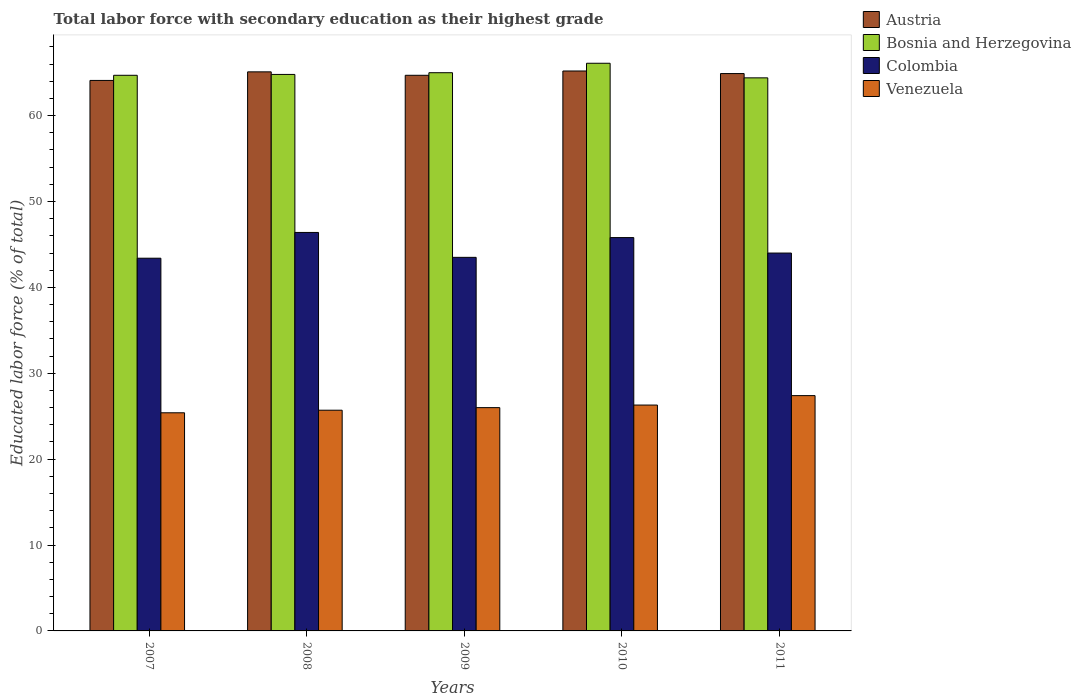How many groups of bars are there?
Your response must be concise. 5. How many bars are there on the 2nd tick from the left?
Offer a very short reply. 4. What is the label of the 1st group of bars from the left?
Offer a very short reply. 2007. In how many cases, is the number of bars for a given year not equal to the number of legend labels?
Your response must be concise. 0. What is the percentage of total labor force with primary education in Austria in 2008?
Ensure brevity in your answer.  65.1. Across all years, what is the maximum percentage of total labor force with primary education in Venezuela?
Your response must be concise. 27.4. Across all years, what is the minimum percentage of total labor force with primary education in Bosnia and Herzegovina?
Your answer should be compact. 64.4. In which year was the percentage of total labor force with primary education in Bosnia and Herzegovina maximum?
Your answer should be compact. 2010. In which year was the percentage of total labor force with primary education in Austria minimum?
Keep it short and to the point. 2007. What is the total percentage of total labor force with primary education in Colombia in the graph?
Make the answer very short. 223.1. What is the difference between the percentage of total labor force with primary education in Colombia in 2007 and that in 2011?
Provide a short and direct response. -0.6. What is the difference between the percentage of total labor force with primary education in Bosnia and Herzegovina in 2007 and the percentage of total labor force with primary education in Austria in 2011?
Provide a succinct answer. -0.2. What is the average percentage of total labor force with primary education in Colombia per year?
Offer a very short reply. 44.62. In the year 2008, what is the difference between the percentage of total labor force with primary education in Venezuela and percentage of total labor force with primary education in Bosnia and Herzegovina?
Give a very brief answer. -39.1. In how many years, is the percentage of total labor force with primary education in Bosnia and Herzegovina greater than 56 %?
Your response must be concise. 5. What is the ratio of the percentage of total labor force with primary education in Venezuela in 2009 to that in 2010?
Give a very brief answer. 0.99. What is the difference between the highest and the second highest percentage of total labor force with primary education in Austria?
Offer a terse response. 0.1. What is the difference between the highest and the lowest percentage of total labor force with primary education in Colombia?
Offer a very short reply. 3. In how many years, is the percentage of total labor force with primary education in Austria greater than the average percentage of total labor force with primary education in Austria taken over all years?
Offer a terse response. 3. Is the sum of the percentage of total labor force with primary education in Venezuela in 2007 and 2009 greater than the maximum percentage of total labor force with primary education in Austria across all years?
Offer a terse response. No. Is it the case that in every year, the sum of the percentage of total labor force with primary education in Bosnia and Herzegovina and percentage of total labor force with primary education in Austria is greater than the sum of percentage of total labor force with primary education in Colombia and percentage of total labor force with primary education in Venezuela?
Give a very brief answer. No. How many bars are there?
Make the answer very short. 20. What is the difference between two consecutive major ticks on the Y-axis?
Your answer should be very brief. 10. Are the values on the major ticks of Y-axis written in scientific E-notation?
Give a very brief answer. No. Does the graph contain any zero values?
Provide a succinct answer. No. Does the graph contain grids?
Give a very brief answer. No. What is the title of the graph?
Your response must be concise. Total labor force with secondary education as their highest grade. What is the label or title of the X-axis?
Your answer should be compact. Years. What is the label or title of the Y-axis?
Offer a very short reply. Educated labor force (% of total). What is the Educated labor force (% of total) of Austria in 2007?
Keep it short and to the point. 64.1. What is the Educated labor force (% of total) of Bosnia and Herzegovina in 2007?
Your response must be concise. 64.7. What is the Educated labor force (% of total) of Colombia in 2007?
Your answer should be compact. 43.4. What is the Educated labor force (% of total) of Venezuela in 2007?
Your answer should be very brief. 25.4. What is the Educated labor force (% of total) of Austria in 2008?
Ensure brevity in your answer.  65.1. What is the Educated labor force (% of total) in Bosnia and Herzegovina in 2008?
Your answer should be compact. 64.8. What is the Educated labor force (% of total) in Colombia in 2008?
Give a very brief answer. 46.4. What is the Educated labor force (% of total) in Venezuela in 2008?
Make the answer very short. 25.7. What is the Educated labor force (% of total) of Austria in 2009?
Give a very brief answer. 64.7. What is the Educated labor force (% of total) in Bosnia and Herzegovina in 2009?
Offer a very short reply. 65. What is the Educated labor force (% of total) in Colombia in 2009?
Your response must be concise. 43.5. What is the Educated labor force (% of total) of Venezuela in 2009?
Keep it short and to the point. 26. What is the Educated labor force (% of total) in Austria in 2010?
Your answer should be very brief. 65.2. What is the Educated labor force (% of total) in Bosnia and Herzegovina in 2010?
Make the answer very short. 66.1. What is the Educated labor force (% of total) in Colombia in 2010?
Keep it short and to the point. 45.8. What is the Educated labor force (% of total) of Venezuela in 2010?
Your answer should be compact. 26.3. What is the Educated labor force (% of total) of Austria in 2011?
Keep it short and to the point. 64.9. What is the Educated labor force (% of total) of Bosnia and Herzegovina in 2011?
Make the answer very short. 64.4. What is the Educated labor force (% of total) in Colombia in 2011?
Your answer should be compact. 44. What is the Educated labor force (% of total) in Venezuela in 2011?
Provide a succinct answer. 27.4. Across all years, what is the maximum Educated labor force (% of total) in Austria?
Make the answer very short. 65.2. Across all years, what is the maximum Educated labor force (% of total) in Bosnia and Herzegovina?
Offer a terse response. 66.1. Across all years, what is the maximum Educated labor force (% of total) of Colombia?
Ensure brevity in your answer.  46.4. Across all years, what is the maximum Educated labor force (% of total) of Venezuela?
Keep it short and to the point. 27.4. Across all years, what is the minimum Educated labor force (% of total) of Austria?
Make the answer very short. 64.1. Across all years, what is the minimum Educated labor force (% of total) of Bosnia and Herzegovina?
Offer a very short reply. 64.4. Across all years, what is the minimum Educated labor force (% of total) in Colombia?
Your answer should be compact. 43.4. Across all years, what is the minimum Educated labor force (% of total) in Venezuela?
Offer a very short reply. 25.4. What is the total Educated labor force (% of total) of Austria in the graph?
Provide a short and direct response. 324. What is the total Educated labor force (% of total) in Bosnia and Herzegovina in the graph?
Offer a very short reply. 325. What is the total Educated labor force (% of total) of Colombia in the graph?
Ensure brevity in your answer.  223.1. What is the total Educated labor force (% of total) in Venezuela in the graph?
Ensure brevity in your answer.  130.8. What is the difference between the Educated labor force (% of total) of Austria in 2007 and that in 2008?
Keep it short and to the point. -1. What is the difference between the Educated labor force (% of total) of Bosnia and Herzegovina in 2007 and that in 2008?
Ensure brevity in your answer.  -0.1. What is the difference between the Educated labor force (% of total) in Venezuela in 2007 and that in 2008?
Offer a very short reply. -0.3. What is the difference between the Educated labor force (% of total) in Austria in 2007 and that in 2009?
Make the answer very short. -0.6. What is the difference between the Educated labor force (% of total) of Bosnia and Herzegovina in 2007 and that in 2009?
Give a very brief answer. -0.3. What is the difference between the Educated labor force (% of total) in Colombia in 2007 and that in 2009?
Provide a short and direct response. -0.1. What is the difference between the Educated labor force (% of total) of Austria in 2007 and that in 2010?
Your response must be concise. -1.1. What is the difference between the Educated labor force (% of total) of Bosnia and Herzegovina in 2007 and that in 2010?
Offer a terse response. -1.4. What is the difference between the Educated labor force (% of total) of Colombia in 2007 and that in 2010?
Ensure brevity in your answer.  -2.4. What is the difference between the Educated labor force (% of total) of Venezuela in 2007 and that in 2010?
Your response must be concise. -0.9. What is the difference between the Educated labor force (% of total) in Austria in 2007 and that in 2011?
Your answer should be compact. -0.8. What is the difference between the Educated labor force (% of total) in Bosnia and Herzegovina in 2007 and that in 2011?
Provide a short and direct response. 0.3. What is the difference between the Educated labor force (% of total) in Colombia in 2007 and that in 2011?
Provide a succinct answer. -0.6. What is the difference between the Educated labor force (% of total) of Bosnia and Herzegovina in 2008 and that in 2009?
Offer a terse response. -0.2. What is the difference between the Educated labor force (% of total) in Colombia in 2008 and that in 2009?
Ensure brevity in your answer.  2.9. What is the difference between the Educated labor force (% of total) in Venezuela in 2008 and that in 2009?
Keep it short and to the point. -0.3. What is the difference between the Educated labor force (% of total) of Austria in 2009 and that in 2010?
Your answer should be compact. -0.5. What is the difference between the Educated labor force (% of total) in Venezuela in 2009 and that in 2010?
Offer a very short reply. -0.3. What is the difference between the Educated labor force (% of total) of Bosnia and Herzegovina in 2009 and that in 2011?
Make the answer very short. 0.6. What is the difference between the Educated labor force (% of total) of Austria in 2010 and that in 2011?
Make the answer very short. 0.3. What is the difference between the Educated labor force (% of total) in Venezuela in 2010 and that in 2011?
Offer a terse response. -1.1. What is the difference between the Educated labor force (% of total) of Austria in 2007 and the Educated labor force (% of total) of Venezuela in 2008?
Keep it short and to the point. 38.4. What is the difference between the Educated labor force (% of total) in Bosnia and Herzegovina in 2007 and the Educated labor force (% of total) in Colombia in 2008?
Offer a very short reply. 18.3. What is the difference between the Educated labor force (% of total) of Bosnia and Herzegovina in 2007 and the Educated labor force (% of total) of Venezuela in 2008?
Ensure brevity in your answer.  39. What is the difference between the Educated labor force (% of total) of Colombia in 2007 and the Educated labor force (% of total) of Venezuela in 2008?
Your response must be concise. 17.7. What is the difference between the Educated labor force (% of total) in Austria in 2007 and the Educated labor force (% of total) in Bosnia and Herzegovina in 2009?
Your answer should be compact. -0.9. What is the difference between the Educated labor force (% of total) of Austria in 2007 and the Educated labor force (% of total) of Colombia in 2009?
Offer a very short reply. 20.6. What is the difference between the Educated labor force (% of total) in Austria in 2007 and the Educated labor force (% of total) in Venezuela in 2009?
Your answer should be compact. 38.1. What is the difference between the Educated labor force (% of total) in Bosnia and Herzegovina in 2007 and the Educated labor force (% of total) in Colombia in 2009?
Your answer should be very brief. 21.2. What is the difference between the Educated labor force (% of total) in Bosnia and Herzegovina in 2007 and the Educated labor force (% of total) in Venezuela in 2009?
Offer a very short reply. 38.7. What is the difference between the Educated labor force (% of total) in Austria in 2007 and the Educated labor force (% of total) in Colombia in 2010?
Your answer should be compact. 18.3. What is the difference between the Educated labor force (% of total) in Austria in 2007 and the Educated labor force (% of total) in Venezuela in 2010?
Provide a short and direct response. 37.8. What is the difference between the Educated labor force (% of total) of Bosnia and Herzegovina in 2007 and the Educated labor force (% of total) of Venezuela in 2010?
Your answer should be very brief. 38.4. What is the difference between the Educated labor force (% of total) of Austria in 2007 and the Educated labor force (% of total) of Bosnia and Herzegovina in 2011?
Offer a very short reply. -0.3. What is the difference between the Educated labor force (% of total) in Austria in 2007 and the Educated labor force (% of total) in Colombia in 2011?
Give a very brief answer. 20.1. What is the difference between the Educated labor force (% of total) in Austria in 2007 and the Educated labor force (% of total) in Venezuela in 2011?
Keep it short and to the point. 36.7. What is the difference between the Educated labor force (% of total) in Bosnia and Herzegovina in 2007 and the Educated labor force (% of total) in Colombia in 2011?
Make the answer very short. 20.7. What is the difference between the Educated labor force (% of total) of Bosnia and Herzegovina in 2007 and the Educated labor force (% of total) of Venezuela in 2011?
Offer a terse response. 37.3. What is the difference between the Educated labor force (% of total) of Colombia in 2007 and the Educated labor force (% of total) of Venezuela in 2011?
Ensure brevity in your answer.  16. What is the difference between the Educated labor force (% of total) in Austria in 2008 and the Educated labor force (% of total) in Colombia in 2009?
Your response must be concise. 21.6. What is the difference between the Educated labor force (% of total) in Austria in 2008 and the Educated labor force (% of total) in Venezuela in 2009?
Your answer should be very brief. 39.1. What is the difference between the Educated labor force (% of total) of Bosnia and Herzegovina in 2008 and the Educated labor force (% of total) of Colombia in 2009?
Give a very brief answer. 21.3. What is the difference between the Educated labor force (% of total) of Bosnia and Herzegovina in 2008 and the Educated labor force (% of total) of Venezuela in 2009?
Keep it short and to the point. 38.8. What is the difference between the Educated labor force (% of total) in Colombia in 2008 and the Educated labor force (% of total) in Venezuela in 2009?
Your answer should be very brief. 20.4. What is the difference between the Educated labor force (% of total) in Austria in 2008 and the Educated labor force (% of total) in Colombia in 2010?
Offer a terse response. 19.3. What is the difference between the Educated labor force (% of total) of Austria in 2008 and the Educated labor force (% of total) of Venezuela in 2010?
Make the answer very short. 38.8. What is the difference between the Educated labor force (% of total) of Bosnia and Herzegovina in 2008 and the Educated labor force (% of total) of Venezuela in 2010?
Ensure brevity in your answer.  38.5. What is the difference between the Educated labor force (% of total) of Colombia in 2008 and the Educated labor force (% of total) of Venezuela in 2010?
Ensure brevity in your answer.  20.1. What is the difference between the Educated labor force (% of total) in Austria in 2008 and the Educated labor force (% of total) in Bosnia and Herzegovina in 2011?
Make the answer very short. 0.7. What is the difference between the Educated labor force (% of total) in Austria in 2008 and the Educated labor force (% of total) in Colombia in 2011?
Provide a short and direct response. 21.1. What is the difference between the Educated labor force (% of total) in Austria in 2008 and the Educated labor force (% of total) in Venezuela in 2011?
Your answer should be very brief. 37.7. What is the difference between the Educated labor force (% of total) in Bosnia and Herzegovina in 2008 and the Educated labor force (% of total) in Colombia in 2011?
Your response must be concise. 20.8. What is the difference between the Educated labor force (% of total) in Bosnia and Herzegovina in 2008 and the Educated labor force (% of total) in Venezuela in 2011?
Offer a terse response. 37.4. What is the difference between the Educated labor force (% of total) in Colombia in 2008 and the Educated labor force (% of total) in Venezuela in 2011?
Make the answer very short. 19. What is the difference between the Educated labor force (% of total) of Austria in 2009 and the Educated labor force (% of total) of Bosnia and Herzegovina in 2010?
Offer a very short reply. -1.4. What is the difference between the Educated labor force (% of total) in Austria in 2009 and the Educated labor force (% of total) in Colombia in 2010?
Ensure brevity in your answer.  18.9. What is the difference between the Educated labor force (% of total) of Austria in 2009 and the Educated labor force (% of total) of Venezuela in 2010?
Offer a terse response. 38.4. What is the difference between the Educated labor force (% of total) of Bosnia and Herzegovina in 2009 and the Educated labor force (% of total) of Venezuela in 2010?
Make the answer very short. 38.7. What is the difference between the Educated labor force (% of total) of Colombia in 2009 and the Educated labor force (% of total) of Venezuela in 2010?
Your answer should be compact. 17.2. What is the difference between the Educated labor force (% of total) of Austria in 2009 and the Educated labor force (% of total) of Colombia in 2011?
Give a very brief answer. 20.7. What is the difference between the Educated labor force (% of total) in Austria in 2009 and the Educated labor force (% of total) in Venezuela in 2011?
Ensure brevity in your answer.  37.3. What is the difference between the Educated labor force (% of total) of Bosnia and Herzegovina in 2009 and the Educated labor force (% of total) of Colombia in 2011?
Offer a terse response. 21. What is the difference between the Educated labor force (% of total) in Bosnia and Herzegovina in 2009 and the Educated labor force (% of total) in Venezuela in 2011?
Offer a terse response. 37.6. What is the difference between the Educated labor force (% of total) in Colombia in 2009 and the Educated labor force (% of total) in Venezuela in 2011?
Provide a succinct answer. 16.1. What is the difference between the Educated labor force (% of total) of Austria in 2010 and the Educated labor force (% of total) of Bosnia and Herzegovina in 2011?
Your answer should be very brief. 0.8. What is the difference between the Educated labor force (% of total) of Austria in 2010 and the Educated labor force (% of total) of Colombia in 2011?
Your answer should be compact. 21.2. What is the difference between the Educated labor force (% of total) in Austria in 2010 and the Educated labor force (% of total) in Venezuela in 2011?
Ensure brevity in your answer.  37.8. What is the difference between the Educated labor force (% of total) of Bosnia and Herzegovina in 2010 and the Educated labor force (% of total) of Colombia in 2011?
Provide a short and direct response. 22.1. What is the difference between the Educated labor force (% of total) of Bosnia and Herzegovina in 2010 and the Educated labor force (% of total) of Venezuela in 2011?
Make the answer very short. 38.7. What is the difference between the Educated labor force (% of total) in Colombia in 2010 and the Educated labor force (% of total) in Venezuela in 2011?
Your answer should be compact. 18.4. What is the average Educated labor force (% of total) in Austria per year?
Your response must be concise. 64.8. What is the average Educated labor force (% of total) of Colombia per year?
Your answer should be very brief. 44.62. What is the average Educated labor force (% of total) in Venezuela per year?
Your answer should be very brief. 26.16. In the year 2007, what is the difference between the Educated labor force (% of total) in Austria and Educated labor force (% of total) in Bosnia and Herzegovina?
Provide a short and direct response. -0.6. In the year 2007, what is the difference between the Educated labor force (% of total) in Austria and Educated labor force (% of total) in Colombia?
Your answer should be compact. 20.7. In the year 2007, what is the difference between the Educated labor force (% of total) of Austria and Educated labor force (% of total) of Venezuela?
Your response must be concise. 38.7. In the year 2007, what is the difference between the Educated labor force (% of total) of Bosnia and Herzegovina and Educated labor force (% of total) of Colombia?
Give a very brief answer. 21.3. In the year 2007, what is the difference between the Educated labor force (% of total) of Bosnia and Herzegovina and Educated labor force (% of total) of Venezuela?
Offer a terse response. 39.3. In the year 2007, what is the difference between the Educated labor force (% of total) of Colombia and Educated labor force (% of total) of Venezuela?
Give a very brief answer. 18. In the year 2008, what is the difference between the Educated labor force (% of total) in Austria and Educated labor force (% of total) in Colombia?
Offer a terse response. 18.7. In the year 2008, what is the difference between the Educated labor force (% of total) in Austria and Educated labor force (% of total) in Venezuela?
Keep it short and to the point. 39.4. In the year 2008, what is the difference between the Educated labor force (% of total) of Bosnia and Herzegovina and Educated labor force (% of total) of Colombia?
Offer a very short reply. 18.4. In the year 2008, what is the difference between the Educated labor force (% of total) of Bosnia and Herzegovina and Educated labor force (% of total) of Venezuela?
Your answer should be compact. 39.1. In the year 2008, what is the difference between the Educated labor force (% of total) in Colombia and Educated labor force (% of total) in Venezuela?
Your answer should be compact. 20.7. In the year 2009, what is the difference between the Educated labor force (% of total) of Austria and Educated labor force (% of total) of Colombia?
Provide a succinct answer. 21.2. In the year 2009, what is the difference between the Educated labor force (% of total) in Austria and Educated labor force (% of total) in Venezuela?
Offer a very short reply. 38.7. In the year 2009, what is the difference between the Educated labor force (% of total) in Bosnia and Herzegovina and Educated labor force (% of total) in Colombia?
Provide a succinct answer. 21.5. In the year 2009, what is the difference between the Educated labor force (% of total) in Colombia and Educated labor force (% of total) in Venezuela?
Your response must be concise. 17.5. In the year 2010, what is the difference between the Educated labor force (% of total) of Austria and Educated labor force (% of total) of Venezuela?
Your answer should be compact. 38.9. In the year 2010, what is the difference between the Educated labor force (% of total) in Bosnia and Herzegovina and Educated labor force (% of total) in Colombia?
Make the answer very short. 20.3. In the year 2010, what is the difference between the Educated labor force (% of total) in Bosnia and Herzegovina and Educated labor force (% of total) in Venezuela?
Provide a short and direct response. 39.8. In the year 2011, what is the difference between the Educated labor force (% of total) of Austria and Educated labor force (% of total) of Colombia?
Your answer should be compact. 20.9. In the year 2011, what is the difference between the Educated labor force (% of total) of Austria and Educated labor force (% of total) of Venezuela?
Ensure brevity in your answer.  37.5. In the year 2011, what is the difference between the Educated labor force (% of total) of Bosnia and Herzegovina and Educated labor force (% of total) of Colombia?
Offer a terse response. 20.4. In the year 2011, what is the difference between the Educated labor force (% of total) in Bosnia and Herzegovina and Educated labor force (% of total) in Venezuela?
Offer a terse response. 37. What is the ratio of the Educated labor force (% of total) in Austria in 2007 to that in 2008?
Offer a very short reply. 0.98. What is the ratio of the Educated labor force (% of total) of Colombia in 2007 to that in 2008?
Ensure brevity in your answer.  0.94. What is the ratio of the Educated labor force (% of total) in Venezuela in 2007 to that in 2008?
Give a very brief answer. 0.99. What is the ratio of the Educated labor force (% of total) in Bosnia and Herzegovina in 2007 to that in 2009?
Your answer should be compact. 1. What is the ratio of the Educated labor force (% of total) of Venezuela in 2007 to that in 2009?
Provide a succinct answer. 0.98. What is the ratio of the Educated labor force (% of total) in Austria in 2007 to that in 2010?
Make the answer very short. 0.98. What is the ratio of the Educated labor force (% of total) in Bosnia and Herzegovina in 2007 to that in 2010?
Your response must be concise. 0.98. What is the ratio of the Educated labor force (% of total) of Colombia in 2007 to that in 2010?
Your response must be concise. 0.95. What is the ratio of the Educated labor force (% of total) of Venezuela in 2007 to that in 2010?
Provide a succinct answer. 0.97. What is the ratio of the Educated labor force (% of total) of Colombia in 2007 to that in 2011?
Give a very brief answer. 0.99. What is the ratio of the Educated labor force (% of total) of Venezuela in 2007 to that in 2011?
Offer a terse response. 0.93. What is the ratio of the Educated labor force (% of total) of Austria in 2008 to that in 2009?
Provide a succinct answer. 1.01. What is the ratio of the Educated labor force (% of total) of Colombia in 2008 to that in 2009?
Offer a terse response. 1.07. What is the ratio of the Educated labor force (% of total) of Bosnia and Herzegovina in 2008 to that in 2010?
Your response must be concise. 0.98. What is the ratio of the Educated labor force (% of total) of Colombia in 2008 to that in 2010?
Keep it short and to the point. 1.01. What is the ratio of the Educated labor force (% of total) in Venezuela in 2008 to that in 2010?
Provide a succinct answer. 0.98. What is the ratio of the Educated labor force (% of total) of Austria in 2008 to that in 2011?
Your answer should be very brief. 1. What is the ratio of the Educated labor force (% of total) of Bosnia and Herzegovina in 2008 to that in 2011?
Give a very brief answer. 1.01. What is the ratio of the Educated labor force (% of total) in Colombia in 2008 to that in 2011?
Offer a very short reply. 1.05. What is the ratio of the Educated labor force (% of total) of Venezuela in 2008 to that in 2011?
Ensure brevity in your answer.  0.94. What is the ratio of the Educated labor force (% of total) in Bosnia and Herzegovina in 2009 to that in 2010?
Offer a terse response. 0.98. What is the ratio of the Educated labor force (% of total) in Colombia in 2009 to that in 2010?
Provide a short and direct response. 0.95. What is the ratio of the Educated labor force (% of total) of Venezuela in 2009 to that in 2010?
Make the answer very short. 0.99. What is the ratio of the Educated labor force (% of total) of Bosnia and Herzegovina in 2009 to that in 2011?
Give a very brief answer. 1.01. What is the ratio of the Educated labor force (% of total) in Venezuela in 2009 to that in 2011?
Keep it short and to the point. 0.95. What is the ratio of the Educated labor force (% of total) in Austria in 2010 to that in 2011?
Provide a succinct answer. 1. What is the ratio of the Educated labor force (% of total) in Bosnia and Herzegovina in 2010 to that in 2011?
Your response must be concise. 1.03. What is the ratio of the Educated labor force (% of total) in Colombia in 2010 to that in 2011?
Offer a terse response. 1.04. What is the ratio of the Educated labor force (% of total) of Venezuela in 2010 to that in 2011?
Make the answer very short. 0.96. What is the difference between the highest and the second highest Educated labor force (% of total) in Austria?
Keep it short and to the point. 0.1. What is the difference between the highest and the second highest Educated labor force (% of total) of Venezuela?
Give a very brief answer. 1.1. What is the difference between the highest and the lowest Educated labor force (% of total) of Colombia?
Provide a short and direct response. 3. What is the difference between the highest and the lowest Educated labor force (% of total) in Venezuela?
Keep it short and to the point. 2. 